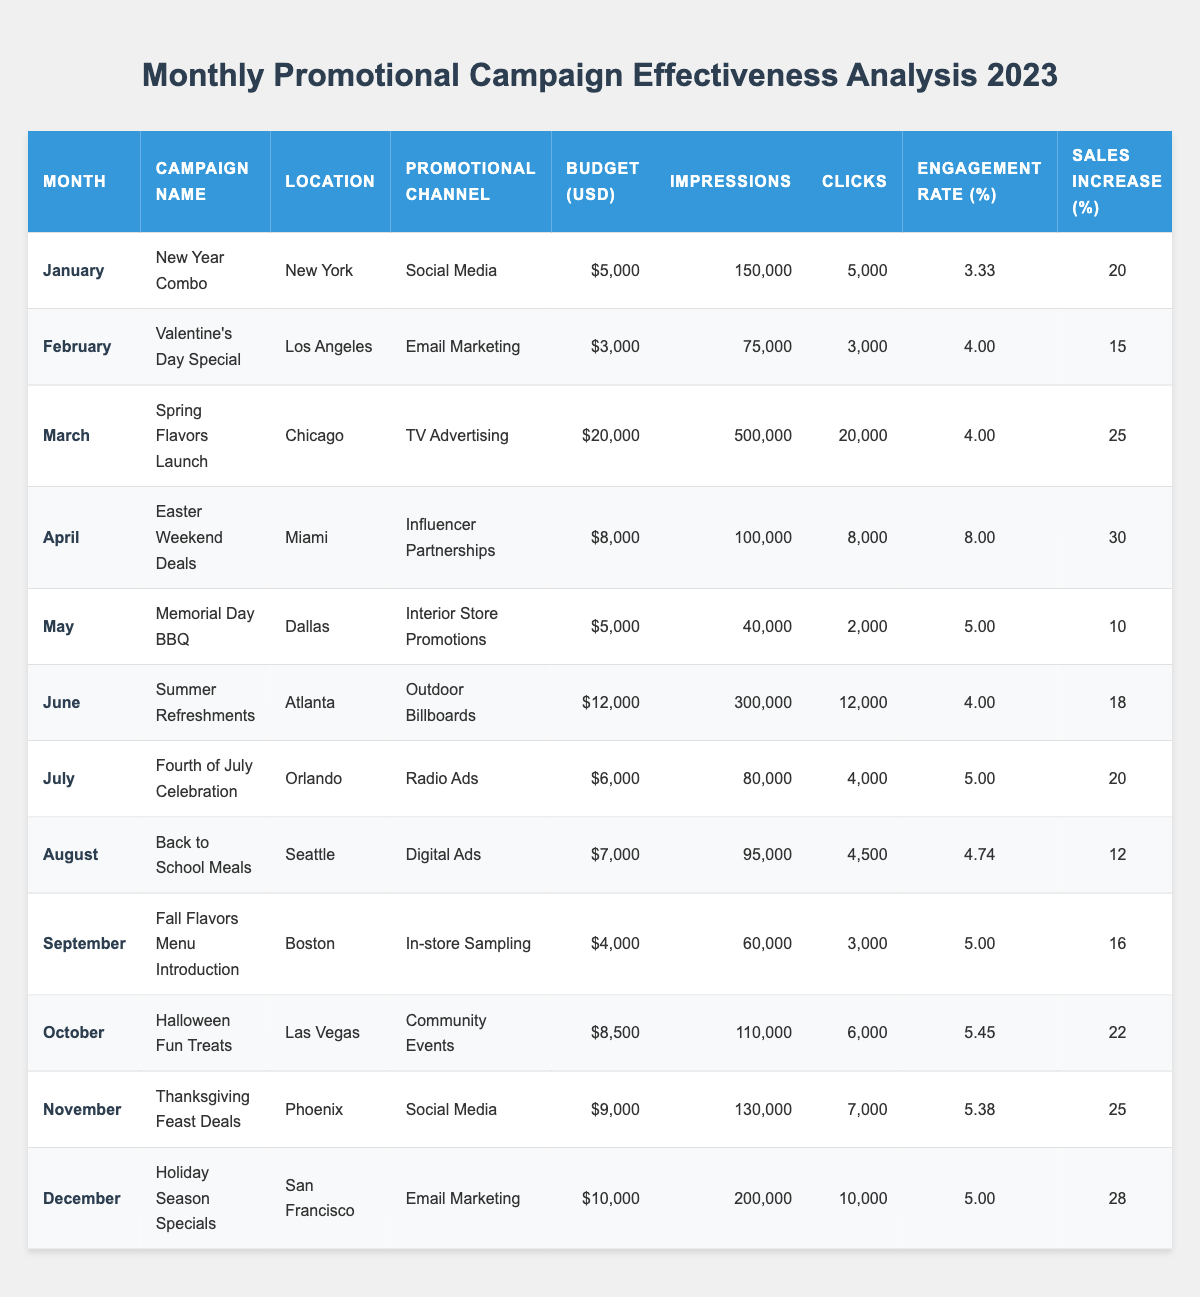What's the total budget allocated for the promotional campaigns in January, February, and March? To find the total budget for these three months, add the budgets for each campaign: January ($5,000) + February ($3,000) + March ($20,000) = $28,000.
Answer: $28,000 Which promotional channel had the highest engagement rate? Refer to the engagement rate column in the table. The highest engagement rate is 8.00% for the "Easter Weekend Deals" campaign in April.
Answer: 8.00% What was the sales increase percentage for the "Halloween Fun Treats" campaign? This information can be found directly in the table under the sales increase percentage for October, which is 22%.
Answer: 22% Did any campaign result in a negative ROI? By examining the ROI column, it is clear that all campaigns have positive ROI values, indicating no campaigns had a negative ROI.
Answer: No What is the average engagement rate for all campaigns conducted in the summer months (June and July)? The engagement rates for June (4.00%) and July (5.00%) are summed up (4.00 + 5.00 = 9.00) and then divided by 2 to find the average: 9.00 / 2 = 4.50%.
Answer: 4.50% Which month had the highest sales increase percentage, and what was that percentage? The highest sales increase percentage is 30% from the "Easter Weekend Deals" campaign in April.
Answer: April, 30% How many total clicks were generated across all campaigns in the first half of the year (January to June)? Sum the clicks from each campaign from January (5,000) to June (12,000): 5,000 + 3,000 + 20,000 + 8,000 + 2,000 + 12,000 = 50,000.
Answer: 50,000 What is the difference in impressions between the best and worst performing campaign based on ROI? The "Easter Weekend Deals" campaign had the highest ROI of 8.0 with impressions of 100,000. The "Memorial Day BBQ" campaign had the lowest ROI of 3.0 with impressions of 40,000. The difference is 100,000 - 40,000 = 60,000.
Answer: 60,000 Which promotional channel had the largest budget, and how much was allocated for it? The largest budget was allocated to "TV Advertising" for the "Spring Flavors Launch" campaign in March, which was $20,000.
Answer: TV Advertising, $20,000 What is the median ROI for the campaigns conducted from January to March? List the ROI values for January (6.5), February (5.0), and March (7.0). When sorted (5.0, 6.5, 7.0), the median is the middle value, which is 6.5.
Answer: 6.5 How many campaigns had a sales increase of 25% or more? By checking each sales increase percentage, three campaigns had a sales increase of 25% or more: "Spring Flavors Launch," "Easter Weekend Deals," and "Holiday Season Specials."
Answer: 3 